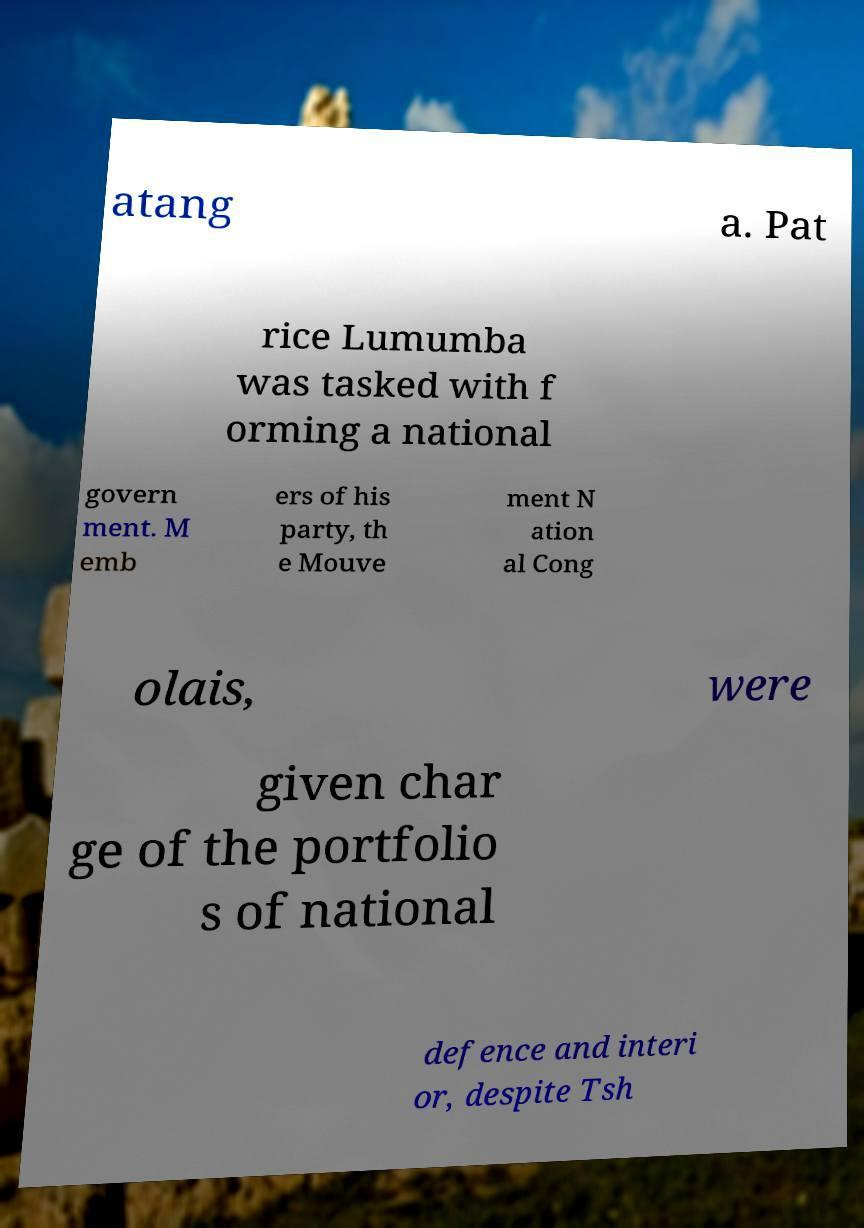What messages or text are displayed in this image? I need them in a readable, typed format. atang a. Pat rice Lumumba was tasked with f orming a national govern ment. M emb ers of his party, th e Mouve ment N ation al Cong olais, were given char ge of the portfolio s of national defence and interi or, despite Tsh 